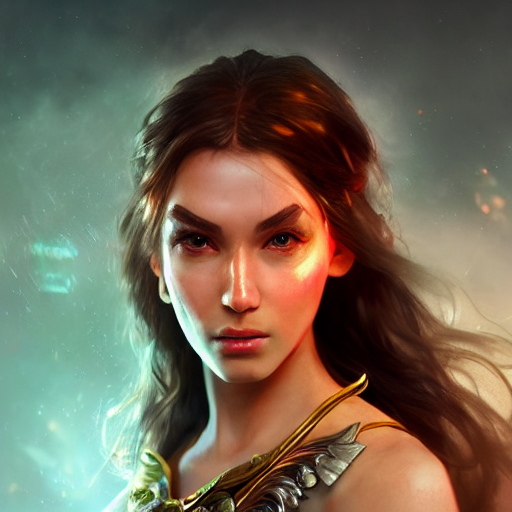Can you describe the setting in which the character is in? The character seems to be engulfed in a mystical or cosmic environment, with an enigmatic glow that shrouds her in an air of fantasy and otherworldliness. What kind of world might this character inhabit? This character might inhabit a world of high-fantasy, where magic intertwines with reality, and ancient myths come to life, presenting a universe where extraordinary beings engage in epic adventures. 